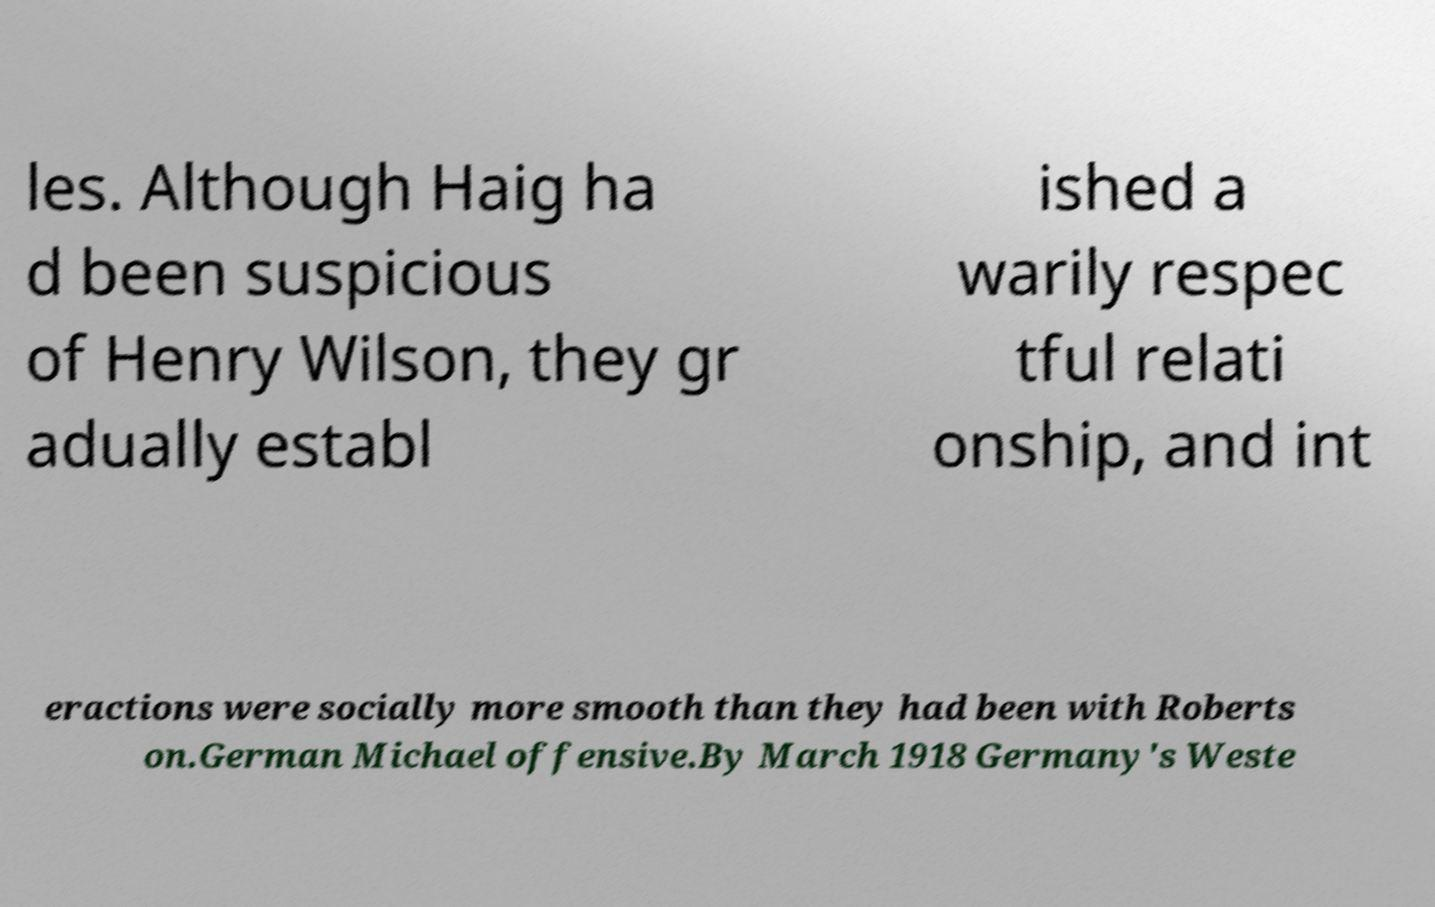What messages or text are displayed in this image? I need them in a readable, typed format. les. Although Haig ha d been suspicious of Henry Wilson, they gr adually establ ished a warily respec tful relati onship, and int eractions were socially more smooth than they had been with Roberts on.German Michael offensive.By March 1918 Germany's Weste 